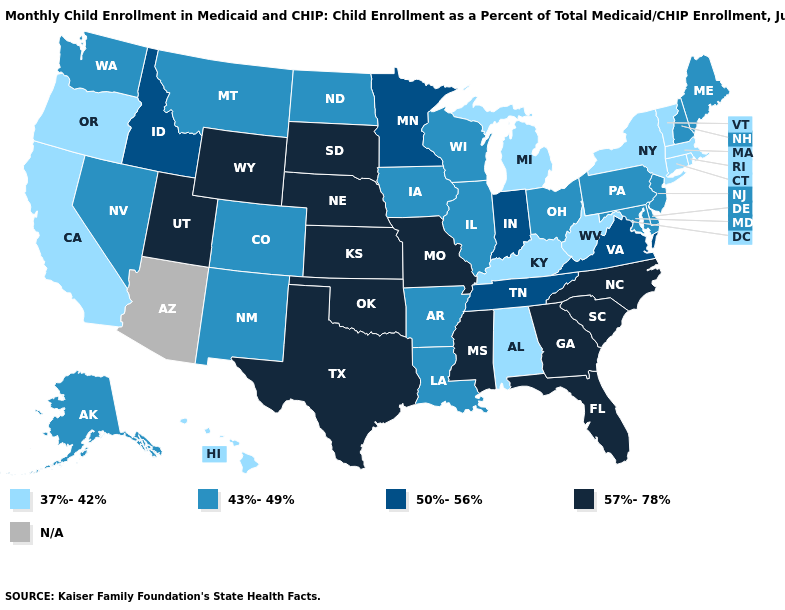Name the states that have a value in the range 43%-49%?
Write a very short answer. Alaska, Arkansas, Colorado, Delaware, Illinois, Iowa, Louisiana, Maine, Maryland, Montana, Nevada, New Hampshire, New Jersey, New Mexico, North Dakota, Ohio, Pennsylvania, Washington, Wisconsin. Name the states that have a value in the range N/A?
Concise answer only. Arizona. What is the highest value in the Northeast ?
Concise answer only. 43%-49%. Does the first symbol in the legend represent the smallest category?
Write a very short answer. Yes. Name the states that have a value in the range 43%-49%?
Be succinct. Alaska, Arkansas, Colorado, Delaware, Illinois, Iowa, Louisiana, Maine, Maryland, Montana, Nevada, New Hampshire, New Jersey, New Mexico, North Dakota, Ohio, Pennsylvania, Washington, Wisconsin. What is the lowest value in states that border Arkansas?
Concise answer only. 43%-49%. Which states have the highest value in the USA?
Give a very brief answer. Florida, Georgia, Kansas, Mississippi, Missouri, Nebraska, North Carolina, Oklahoma, South Carolina, South Dakota, Texas, Utah, Wyoming. Is the legend a continuous bar?
Answer briefly. No. Among the states that border Arkansas , does Texas have the lowest value?
Concise answer only. No. What is the value of New Mexico?
Quick response, please. 43%-49%. What is the highest value in the South ?
Keep it brief. 57%-78%. Name the states that have a value in the range N/A?
Concise answer only. Arizona. Which states have the lowest value in the South?
Short answer required. Alabama, Kentucky, West Virginia. 